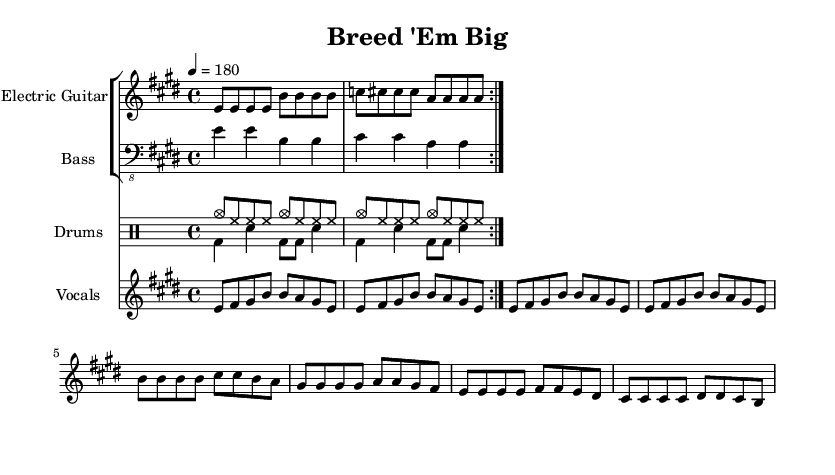What is the key signature of this music? The key signature is E major, which has four sharps (F#, C#, G#, D#).
Answer: E major What is the time signature of this music? The time signature is four-four, meaning there are four beats in a measure.
Answer: 4/4 What is the tempo marking for this piece? The tempo marking is indicated as quarter note equals 180 beats per minute, which is a fast pace for punk rock.
Answer: 180 How many times is the verse repeated? The verse section is repeated twice as indicated by the volta notation after the first line of the melody.
Answer: 2 What genres can be identified in this music? The piece is specifically categorized as punk rock, incorporating energy and quick tempo, along with themes related to animal breeding.
Answer: Punk rock Which animal breeds are celebrated in the lyrics? The lyrics mention Mastiffs, Great Danes, and Newfoundlands as the big dog breeds being celebrated by breeders.
Answer: Mastiffs, Danes, Newfoundlands What instruments are featured in this arrangement? The arrangement includes electric guitar, bass guitar, drums, and vocals as highlighted in the musical score.
Answer: Electric guitar, bass, drums, vocals 